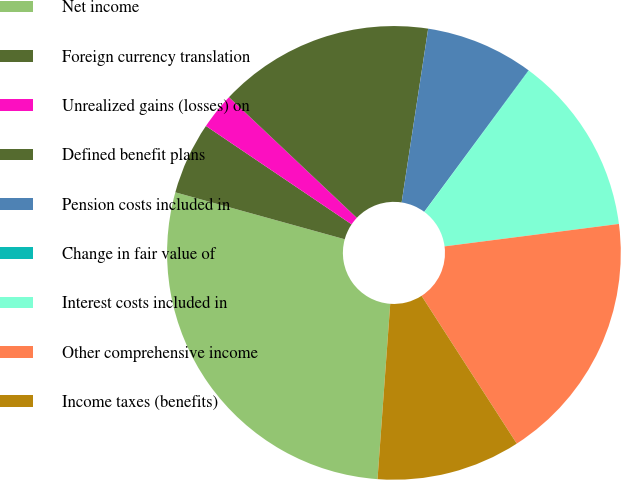Convert chart to OTSL. <chart><loc_0><loc_0><loc_500><loc_500><pie_chart><fcel>Net income<fcel>Foreign currency translation<fcel>Unrealized gains (losses) on<fcel>Defined benefit plans<fcel>Pension costs included in<fcel>Change in fair value of<fcel>Interest costs included in<fcel>Other comprehensive income<fcel>Income taxes (benefits)<nl><fcel>28.15%<fcel>5.15%<fcel>2.59%<fcel>15.37%<fcel>7.7%<fcel>0.03%<fcel>12.82%<fcel>17.93%<fcel>10.26%<nl></chart> 